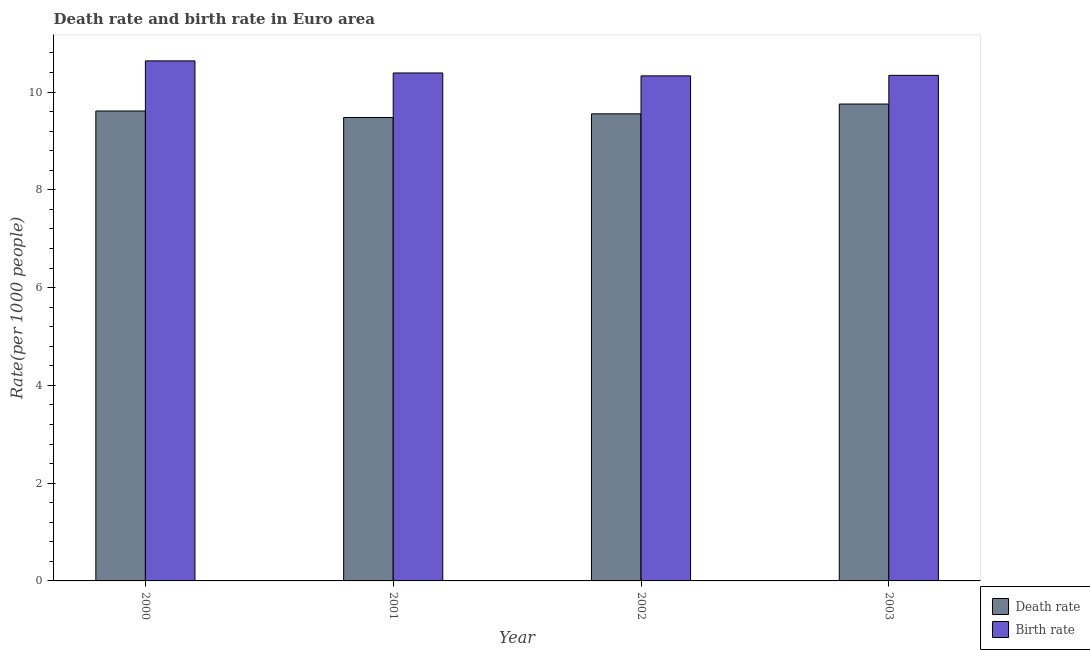How many different coloured bars are there?
Provide a succinct answer. 2. Are the number of bars per tick equal to the number of legend labels?
Your response must be concise. Yes. How many bars are there on the 2nd tick from the left?
Your response must be concise. 2. How many bars are there on the 3rd tick from the right?
Your response must be concise. 2. What is the birth rate in 2002?
Provide a succinct answer. 10.33. Across all years, what is the maximum birth rate?
Offer a terse response. 10.64. Across all years, what is the minimum death rate?
Provide a succinct answer. 9.48. What is the total birth rate in the graph?
Keep it short and to the point. 41.7. What is the difference between the birth rate in 2001 and that in 2002?
Provide a short and direct response. 0.06. What is the difference between the birth rate in 2003 and the death rate in 2002?
Offer a terse response. 0.01. What is the average birth rate per year?
Provide a short and direct response. 10.43. What is the ratio of the death rate in 2001 to that in 2002?
Offer a terse response. 0.99. Is the difference between the death rate in 2000 and 2001 greater than the difference between the birth rate in 2000 and 2001?
Keep it short and to the point. No. What is the difference between the highest and the second highest death rate?
Your response must be concise. 0.14. What is the difference between the highest and the lowest death rate?
Provide a succinct answer. 0.28. In how many years, is the death rate greater than the average death rate taken over all years?
Provide a short and direct response. 2. Is the sum of the death rate in 2001 and 2003 greater than the maximum birth rate across all years?
Give a very brief answer. Yes. What does the 1st bar from the left in 2003 represents?
Your answer should be compact. Death rate. What does the 1st bar from the right in 2000 represents?
Your response must be concise. Birth rate. How many bars are there?
Offer a terse response. 8. Are all the bars in the graph horizontal?
Provide a short and direct response. No. Are the values on the major ticks of Y-axis written in scientific E-notation?
Ensure brevity in your answer.  No. Where does the legend appear in the graph?
Your response must be concise. Bottom right. How many legend labels are there?
Your answer should be very brief. 2. How are the legend labels stacked?
Your answer should be very brief. Vertical. What is the title of the graph?
Your answer should be very brief. Death rate and birth rate in Euro area. Does "Manufacturing industries and construction" appear as one of the legend labels in the graph?
Offer a terse response. No. What is the label or title of the X-axis?
Provide a short and direct response. Year. What is the label or title of the Y-axis?
Your response must be concise. Rate(per 1000 people). What is the Rate(per 1000 people) of Death rate in 2000?
Provide a succinct answer. 9.61. What is the Rate(per 1000 people) in Birth rate in 2000?
Give a very brief answer. 10.64. What is the Rate(per 1000 people) of Death rate in 2001?
Offer a terse response. 9.48. What is the Rate(per 1000 people) in Birth rate in 2001?
Keep it short and to the point. 10.39. What is the Rate(per 1000 people) of Death rate in 2002?
Your answer should be very brief. 9.55. What is the Rate(per 1000 people) of Birth rate in 2002?
Your response must be concise. 10.33. What is the Rate(per 1000 people) of Death rate in 2003?
Provide a short and direct response. 9.76. What is the Rate(per 1000 people) in Birth rate in 2003?
Your answer should be compact. 10.34. Across all years, what is the maximum Rate(per 1000 people) in Death rate?
Offer a very short reply. 9.76. Across all years, what is the maximum Rate(per 1000 people) of Birth rate?
Offer a very short reply. 10.64. Across all years, what is the minimum Rate(per 1000 people) in Death rate?
Provide a succinct answer. 9.48. Across all years, what is the minimum Rate(per 1000 people) of Birth rate?
Your answer should be compact. 10.33. What is the total Rate(per 1000 people) in Death rate in the graph?
Your answer should be compact. 38.4. What is the total Rate(per 1000 people) of Birth rate in the graph?
Give a very brief answer. 41.7. What is the difference between the Rate(per 1000 people) in Death rate in 2000 and that in 2001?
Make the answer very short. 0.13. What is the difference between the Rate(per 1000 people) in Birth rate in 2000 and that in 2001?
Provide a succinct answer. 0.25. What is the difference between the Rate(per 1000 people) in Death rate in 2000 and that in 2002?
Your answer should be very brief. 0.06. What is the difference between the Rate(per 1000 people) of Birth rate in 2000 and that in 2002?
Your response must be concise. 0.31. What is the difference between the Rate(per 1000 people) in Death rate in 2000 and that in 2003?
Make the answer very short. -0.14. What is the difference between the Rate(per 1000 people) of Birth rate in 2000 and that in 2003?
Your response must be concise. 0.3. What is the difference between the Rate(per 1000 people) of Death rate in 2001 and that in 2002?
Your response must be concise. -0.07. What is the difference between the Rate(per 1000 people) of Birth rate in 2001 and that in 2002?
Ensure brevity in your answer.  0.06. What is the difference between the Rate(per 1000 people) of Death rate in 2001 and that in 2003?
Offer a very short reply. -0.28. What is the difference between the Rate(per 1000 people) of Birth rate in 2001 and that in 2003?
Your answer should be compact. 0.05. What is the difference between the Rate(per 1000 people) of Death rate in 2002 and that in 2003?
Give a very brief answer. -0.2. What is the difference between the Rate(per 1000 people) of Birth rate in 2002 and that in 2003?
Keep it short and to the point. -0.01. What is the difference between the Rate(per 1000 people) in Death rate in 2000 and the Rate(per 1000 people) in Birth rate in 2001?
Your response must be concise. -0.78. What is the difference between the Rate(per 1000 people) of Death rate in 2000 and the Rate(per 1000 people) of Birth rate in 2002?
Your answer should be compact. -0.72. What is the difference between the Rate(per 1000 people) in Death rate in 2000 and the Rate(per 1000 people) in Birth rate in 2003?
Offer a terse response. -0.73. What is the difference between the Rate(per 1000 people) of Death rate in 2001 and the Rate(per 1000 people) of Birth rate in 2002?
Make the answer very short. -0.85. What is the difference between the Rate(per 1000 people) in Death rate in 2001 and the Rate(per 1000 people) in Birth rate in 2003?
Your response must be concise. -0.86. What is the difference between the Rate(per 1000 people) in Death rate in 2002 and the Rate(per 1000 people) in Birth rate in 2003?
Your answer should be compact. -0.79. What is the average Rate(per 1000 people) in Death rate per year?
Your answer should be compact. 9.6. What is the average Rate(per 1000 people) of Birth rate per year?
Your answer should be very brief. 10.43. In the year 2000, what is the difference between the Rate(per 1000 people) of Death rate and Rate(per 1000 people) of Birth rate?
Your response must be concise. -1.03. In the year 2001, what is the difference between the Rate(per 1000 people) in Death rate and Rate(per 1000 people) in Birth rate?
Ensure brevity in your answer.  -0.91. In the year 2002, what is the difference between the Rate(per 1000 people) of Death rate and Rate(per 1000 people) of Birth rate?
Provide a succinct answer. -0.78. In the year 2003, what is the difference between the Rate(per 1000 people) in Death rate and Rate(per 1000 people) in Birth rate?
Offer a very short reply. -0.59. What is the ratio of the Rate(per 1000 people) of Birth rate in 2000 to that in 2001?
Give a very brief answer. 1.02. What is the ratio of the Rate(per 1000 people) in Birth rate in 2000 to that in 2002?
Offer a terse response. 1.03. What is the ratio of the Rate(per 1000 people) of Death rate in 2000 to that in 2003?
Provide a succinct answer. 0.99. What is the ratio of the Rate(per 1000 people) of Birth rate in 2000 to that in 2003?
Offer a terse response. 1.03. What is the ratio of the Rate(per 1000 people) in Death rate in 2001 to that in 2002?
Provide a succinct answer. 0.99. What is the ratio of the Rate(per 1000 people) of Death rate in 2001 to that in 2003?
Your answer should be compact. 0.97. What is the ratio of the Rate(per 1000 people) in Birth rate in 2001 to that in 2003?
Your response must be concise. 1. What is the ratio of the Rate(per 1000 people) of Death rate in 2002 to that in 2003?
Offer a very short reply. 0.98. What is the ratio of the Rate(per 1000 people) in Birth rate in 2002 to that in 2003?
Your answer should be very brief. 1. What is the difference between the highest and the second highest Rate(per 1000 people) in Death rate?
Keep it short and to the point. 0.14. What is the difference between the highest and the second highest Rate(per 1000 people) of Birth rate?
Offer a very short reply. 0.25. What is the difference between the highest and the lowest Rate(per 1000 people) of Death rate?
Your answer should be very brief. 0.28. What is the difference between the highest and the lowest Rate(per 1000 people) in Birth rate?
Your answer should be very brief. 0.31. 